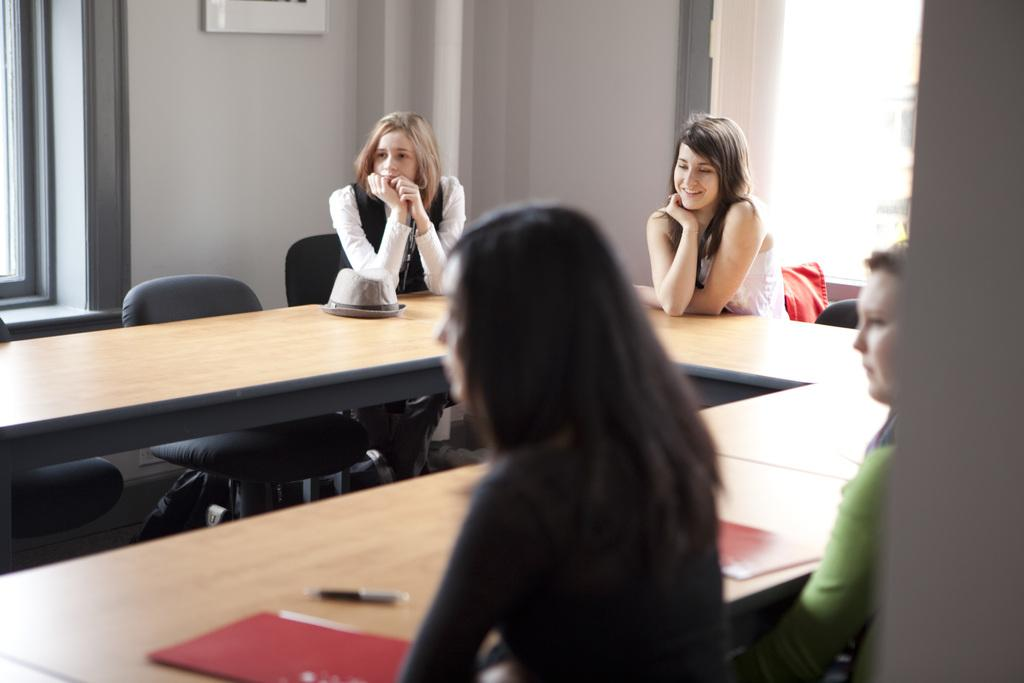How many people are present in the image? There are four persons in the image. What are the persons doing in the image? The persons are sitting on chairs. What can be seen on the table in the image? There is a file and a pen on the table. What is visible in the background of the image? There is a wall in the background of the image. What type of car is parked on the roof in the image? There is no car or roof present in the image. How low is the table in the image? The height of the table is not mentioned in the image, but it appears to be a standard table height. 